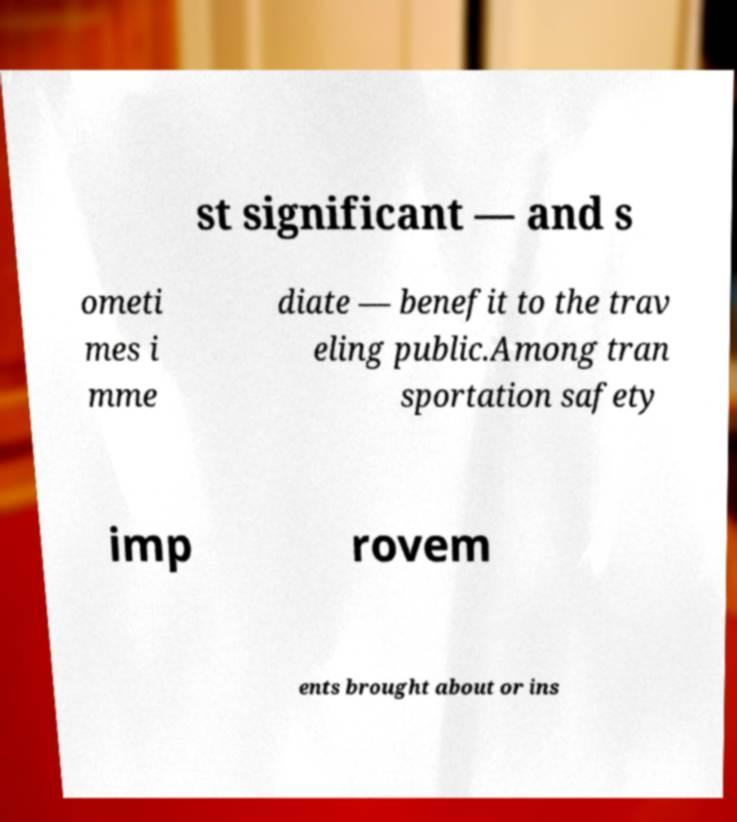Please identify and transcribe the text found in this image. st significant — and s ometi mes i mme diate — benefit to the trav eling public.Among tran sportation safety imp rovem ents brought about or ins 